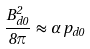Convert formula to latex. <formula><loc_0><loc_0><loc_500><loc_500>\frac { B _ { d 0 } ^ { 2 } } { 8 \pi } \, \approx \, \alpha \, p _ { d 0 }</formula> 